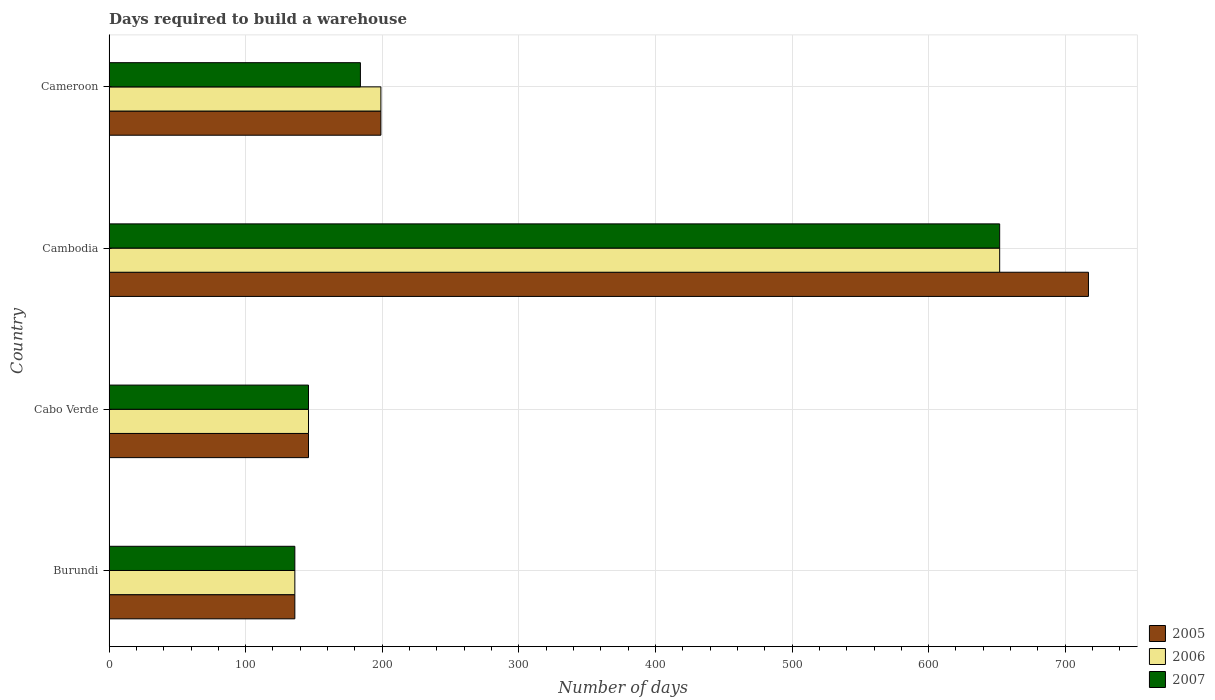How many different coloured bars are there?
Keep it short and to the point. 3. Are the number of bars per tick equal to the number of legend labels?
Keep it short and to the point. Yes. Are the number of bars on each tick of the Y-axis equal?
Ensure brevity in your answer.  Yes. How many bars are there on the 4th tick from the bottom?
Offer a very short reply. 3. What is the label of the 3rd group of bars from the top?
Provide a short and direct response. Cabo Verde. What is the days required to build a warehouse in in 2007 in Cameroon?
Your answer should be compact. 184. Across all countries, what is the maximum days required to build a warehouse in in 2007?
Provide a succinct answer. 652. Across all countries, what is the minimum days required to build a warehouse in in 2007?
Offer a very short reply. 136. In which country was the days required to build a warehouse in in 2007 maximum?
Your response must be concise. Cambodia. In which country was the days required to build a warehouse in in 2005 minimum?
Provide a short and direct response. Burundi. What is the total days required to build a warehouse in in 2007 in the graph?
Ensure brevity in your answer.  1118. What is the difference between the days required to build a warehouse in in 2005 in Cambodia and that in Cameroon?
Offer a terse response. 518. What is the difference between the days required to build a warehouse in in 2006 in Cabo Verde and the days required to build a warehouse in in 2005 in Cambodia?
Provide a succinct answer. -571. What is the average days required to build a warehouse in in 2007 per country?
Give a very brief answer. 279.5. What is the difference between the days required to build a warehouse in in 2005 and days required to build a warehouse in in 2006 in Cambodia?
Provide a short and direct response. 65. In how many countries, is the days required to build a warehouse in in 2007 greater than 700 days?
Ensure brevity in your answer.  0. What is the ratio of the days required to build a warehouse in in 2006 in Cabo Verde to that in Cambodia?
Offer a very short reply. 0.22. Is the difference between the days required to build a warehouse in in 2005 in Burundi and Cameroon greater than the difference between the days required to build a warehouse in in 2006 in Burundi and Cameroon?
Your answer should be very brief. No. What is the difference between the highest and the second highest days required to build a warehouse in in 2007?
Offer a terse response. 468. What is the difference between the highest and the lowest days required to build a warehouse in in 2007?
Provide a short and direct response. 516. In how many countries, is the days required to build a warehouse in in 2006 greater than the average days required to build a warehouse in in 2006 taken over all countries?
Give a very brief answer. 1. Is the sum of the days required to build a warehouse in in 2005 in Burundi and Cameroon greater than the maximum days required to build a warehouse in in 2006 across all countries?
Provide a succinct answer. No. What does the 2nd bar from the top in Cameroon represents?
Your answer should be compact. 2006. What does the 2nd bar from the bottom in Burundi represents?
Make the answer very short. 2006. Is it the case that in every country, the sum of the days required to build a warehouse in in 2005 and days required to build a warehouse in in 2007 is greater than the days required to build a warehouse in in 2006?
Give a very brief answer. Yes. Are all the bars in the graph horizontal?
Offer a very short reply. Yes. How many countries are there in the graph?
Your answer should be compact. 4. What is the difference between two consecutive major ticks on the X-axis?
Ensure brevity in your answer.  100. Does the graph contain grids?
Provide a succinct answer. Yes. Where does the legend appear in the graph?
Your response must be concise. Bottom right. How many legend labels are there?
Your answer should be compact. 3. How are the legend labels stacked?
Provide a succinct answer. Vertical. What is the title of the graph?
Give a very brief answer. Days required to build a warehouse. Does "1980" appear as one of the legend labels in the graph?
Your answer should be very brief. No. What is the label or title of the X-axis?
Offer a terse response. Number of days. What is the Number of days in 2005 in Burundi?
Provide a short and direct response. 136. What is the Number of days in 2006 in Burundi?
Offer a terse response. 136. What is the Number of days of 2007 in Burundi?
Provide a short and direct response. 136. What is the Number of days in 2005 in Cabo Verde?
Ensure brevity in your answer.  146. What is the Number of days of 2006 in Cabo Verde?
Ensure brevity in your answer.  146. What is the Number of days in 2007 in Cabo Verde?
Make the answer very short. 146. What is the Number of days in 2005 in Cambodia?
Provide a short and direct response. 717. What is the Number of days in 2006 in Cambodia?
Offer a terse response. 652. What is the Number of days of 2007 in Cambodia?
Provide a short and direct response. 652. What is the Number of days of 2005 in Cameroon?
Your answer should be compact. 199. What is the Number of days of 2006 in Cameroon?
Make the answer very short. 199. What is the Number of days in 2007 in Cameroon?
Offer a terse response. 184. Across all countries, what is the maximum Number of days in 2005?
Your answer should be compact. 717. Across all countries, what is the maximum Number of days of 2006?
Your response must be concise. 652. Across all countries, what is the maximum Number of days of 2007?
Make the answer very short. 652. Across all countries, what is the minimum Number of days of 2005?
Provide a short and direct response. 136. Across all countries, what is the minimum Number of days of 2006?
Give a very brief answer. 136. Across all countries, what is the minimum Number of days in 2007?
Your response must be concise. 136. What is the total Number of days in 2005 in the graph?
Provide a short and direct response. 1198. What is the total Number of days of 2006 in the graph?
Ensure brevity in your answer.  1133. What is the total Number of days in 2007 in the graph?
Provide a succinct answer. 1118. What is the difference between the Number of days in 2006 in Burundi and that in Cabo Verde?
Your response must be concise. -10. What is the difference between the Number of days in 2005 in Burundi and that in Cambodia?
Offer a very short reply. -581. What is the difference between the Number of days of 2006 in Burundi and that in Cambodia?
Offer a very short reply. -516. What is the difference between the Number of days in 2007 in Burundi and that in Cambodia?
Provide a succinct answer. -516. What is the difference between the Number of days in 2005 in Burundi and that in Cameroon?
Ensure brevity in your answer.  -63. What is the difference between the Number of days of 2006 in Burundi and that in Cameroon?
Make the answer very short. -63. What is the difference between the Number of days in 2007 in Burundi and that in Cameroon?
Offer a terse response. -48. What is the difference between the Number of days of 2005 in Cabo Verde and that in Cambodia?
Provide a short and direct response. -571. What is the difference between the Number of days in 2006 in Cabo Verde and that in Cambodia?
Make the answer very short. -506. What is the difference between the Number of days in 2007 in Cabo Verde and that in Cambodia?
Provide a short and direct response. -506. What is the difference between the Number of days of 2005 in Cabo Verde and that in Cameroon?
Give a very brief answer. -53. What is the difference between the Number of days of 2006 in Cabo Verde and that in Cameroon?
Your response must be concise. -53. What is the difference between the Number of days in 2007 in Cabo Verde and that in Cameroon?
Offer a very short reply. -38. What is the difference between the Number of days in 2005 in Cambodia and that in Cameroon?
Keep it short and to the point. 518. What is the difference between the Number of days in 2006 in Cambodia and that in Cameroon?
Provide a succinct answer. 453. What is the difference between the Number of days in 2007 in Cambodia and that in Cameroon?
Ensure brevity in your answer.  468. What is the difference between the Number of days of 2005 in Burundi and the Number of days of 2007 in Cabo Verde?
Keep it short and to the point. -10. What is the difference between the Number of days in 2005 in Burundi and the Number of days in 2006 in Cambodia?
Ensure brevity in your answer.  -516. What is the difference between the Number of days in 2005 in Burundi and the Number of days in 2007 in Cambodia?
Your answer should be very brief. -516. What is the difference between the Number of days of 2006 in Burundi and the Number of days of 2007 in Cambodia?
Offer a very short reply. -516. What is the difference between the Number of days of 2005 in Burundi and the Number of days of 2006 in Cameroon?
Provide a succinct answer. -63. What is the difference between the Number of days of 2005 in Burundi and the Number of days of 2007 in Cameroon?
Offer a very short reply. -48. What is the difference between the Number of days in 2006 in Burundi and the Number of days in 2007 in Cameroon?
Offer a very short reply. -48. What is the difference between the Number of days of 2005 in Cabo Verde and the Number of days of 2006 in Cambodia?
Your response must be concise. -506. What is the difference between the Number of days in 2005 in Cabo Verde and the Number of days in 2007 in Cambodia?
Ensure brevity in your answer.  -506. What is the difference between the Number of days in 2006 in Cabo Verde and the Number of days in 2007 in Cambodia?
Provide a short and direct response. -506. What is the difference between the Number of days in 2005 in Cabo Verde and the Number of days in 2006 in Cameroon?
Give a very brief answer. -53. What is the difference between the Number of days in 2005 in Cabo Verde and the Number of days in 2007 in Cameroon?
Ensure brevity in your answer.  -38. What is the difference between the Number of days of 2006 in Cabo Verde and the Number of days of 2007 in Cameroon?
Your answer should be very brief. -38. What is the difference between the Number of days of 2005 in Cambodia and the Number of days of 2006 in Cameroon?
Your answer should be very brief. 518. What is the difference between the Number of days of 2005 in Cambodia and the Number of days of 2007 in Cameroon?
Offer a terse response. 533. What is the difference between the Number of days of 2006 in Cambodia and the Number of days of 2007 in Cameroon?
Provide a short and direct response. 468. What is the average Number of days of 2005 per country?
Offer a terse response. 299.5. What is the average Number of days of 2006 per country?
Give a very brief answer. 283.25. What is the average Number of days in 2007 per country?
Provide a short and direct response. 279.5. What is the difference between the Number of days of 2005 and Number of days of 2007 in Burundi?
Your answer should be compact. 0. What is the difference between the Number of days in 2006 and Number of days in 2007 in Burundi?
Your answer should be very brief. 0. What is the difference between the Number of days of 2005 and Number of days of 2006 in Cambodia?
Your answer should be compact. 65. What is the difference between the Number of days of 2005 and Number of days of 2007 in Cambodia?
Provide a short and direct response. 65. What is the ratio of the Number of days in 2005 in Burundi to that in Cabo Verde?
Your answer should be compact. 0.93. What is the ratio of the Number of days of 2006 in Burundi to that in Cabo Verde?
Your answer should be compact. 0.93. What is the ratio of the Number of days of 2007 in Burundi to that in Cabo Verde?
Offer a terse response. 0.93. What is the ratio of the Number of days in 2005 in Burundi to that in Cambodia?
Give a very brief answer. 0.19. What is the ratio of the Number of days in 2006 in Burundi to that in Cambodia?
Your answer should be compact. 0.21. What is the ratio of the Number of days of 2007 in Burundi to that in Cambodia?
Ensure brevity in your answer.  0.21. What is the ratio of the Number of days in 2005 in Burundi to that in Cameroon?
Provide a succinct answer. 0.68. What is the ratio of the Number of days of 2006 in Burundi to that in Cameroon?
Ensure brevity in your answer.  0.68. What is the ratio of the Number of days of 2007 in Burundi to that in Cameroon?
Ensure brevity in your answer.  0.74. What is the ratio of the Number of days of 2005 in Cabo Verde to that in Cambodia?
Ensure brevity in your answer.  0.2. What is the ratio of the Number of days of 2006 in Cabo Verde to that in Cambodia?
Give a very brief answer. 0.22. What is the ratio of the Number of days of 2007 in Cabo Verde to that in Cambodia?
Your answer should be very brief. 0.22. What is the ratio of the Number of days of 2005 in Cabo Verde to that in Cameroon?
Make the answer very short. 0.73. What is the ratio of the Number of days of 2006 in Cabo Verde to that in Cameroon?
Make the answer very short. 0.73. What is the ratio of the Number of days in 2007 in Cabo Verde to that in Cameroon?
Your answer should be very brief. 0.79. What is the ratio of the Number of days in 2005 in Cambodia to that in Cameroon?
Offer a very short reply. 3.6. What is the ratio of the Number of days of 2006 in Cambodia to that in Cameroon?
Offer a very short reply. 3.28. What is the ratio of the Number of days of 2007 in Cambodia to that in Cameroon?
Offer a terse response. 3.54. What is the difference between the highest and the second highest Number of days in 2005?
Offer a very short reply. 518. What is the difference between the highest and the second highest Number of days in 2006?
Your response must be concise. 453. What is the difference between the highest and the second highest Number of days of 2007?
Provide a succinct answer. 468. What is the difference between the highest and the lowest Number of days of 2005?
Give a very brief answer. 581. What is the difference between the highest and the lowest Number of days of 2006?
Your answer should be compact. 516. What is the difference between the highest and the lowest Number of days of 2007?
Your response must be concise. 516. 